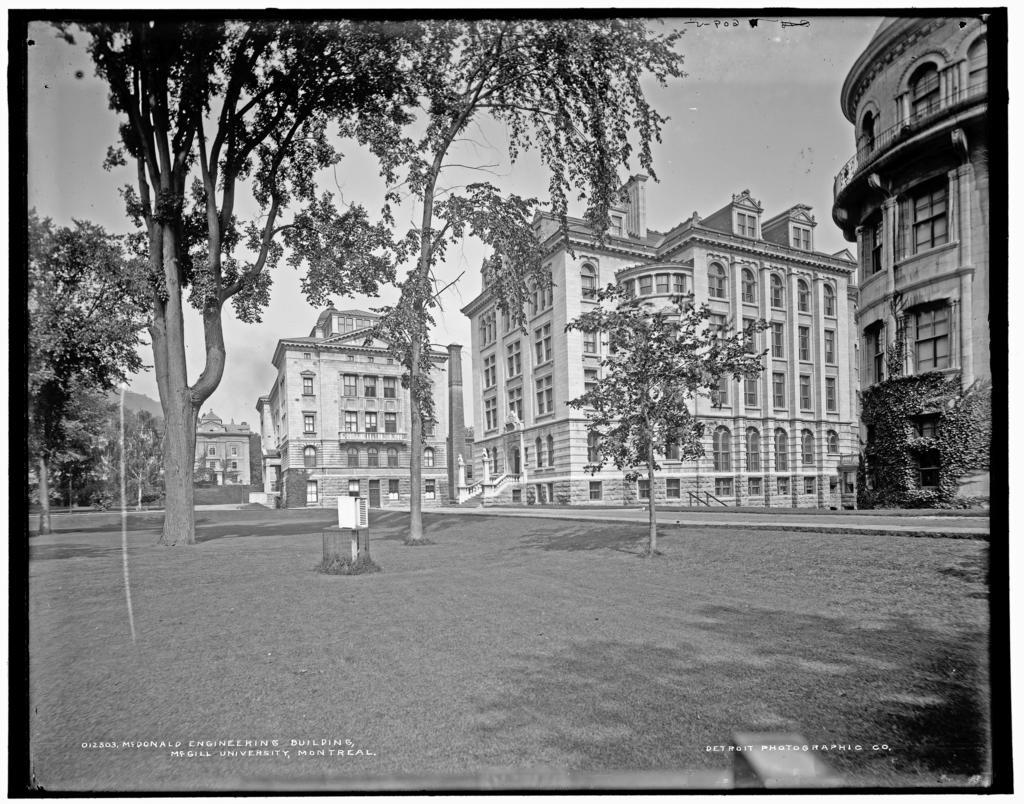What type of natural elements can be seen in the image? There are trees and plants in the image. What man-made structures are visible in the image? There are buildings in the image. What type of pathway is present in the image? There is a road in the image. What is the color scheme of the image? The image is black and white. What type of cakes are being served at the point in the image? There are no cakes or points present in the image; it features trees, plants, a road, buildings, and is in black and white. What day of the week is depicted in the image? The image does not depict a specific day of the week; it is a still image without any indication of time. 